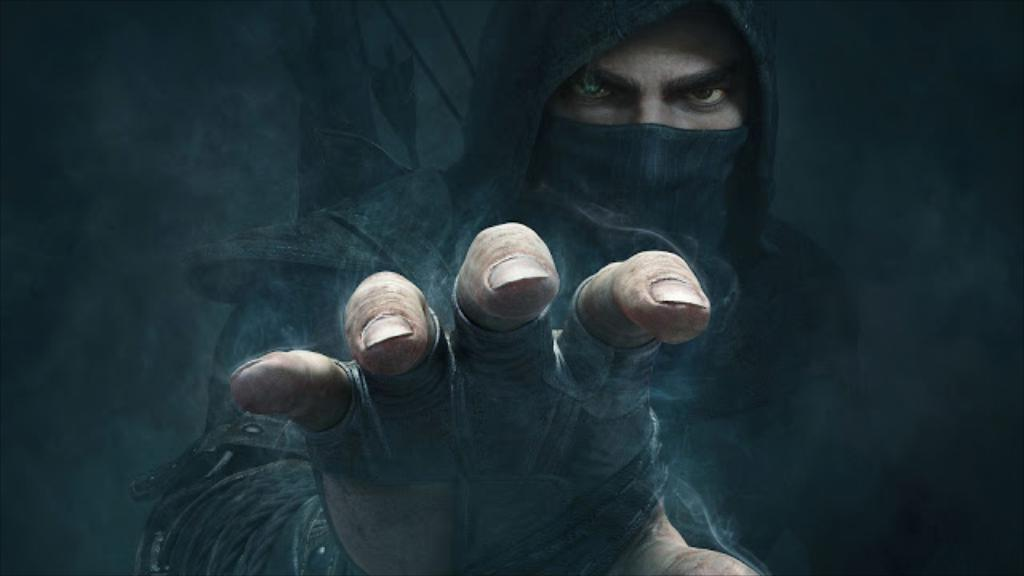What type of image is being described? The image is animated. Can you describe any characters or figures in the image? There is a man in the image. What color is the kitty's suit in the image? There is no kitty or suit present in the image; it only features an animated man. 